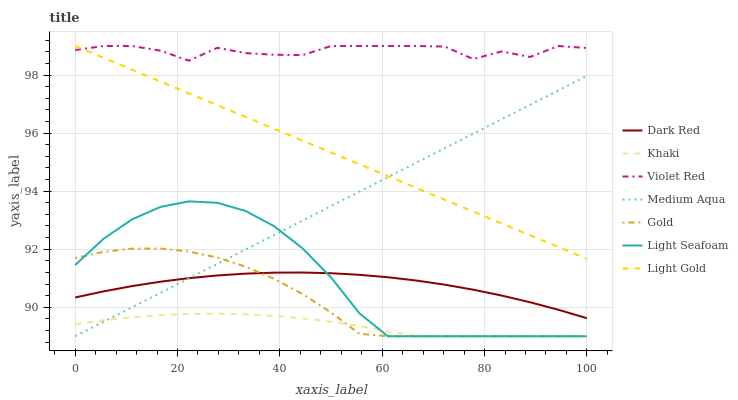Does Khaki have the minimum area under the curve?
Answer yes or no. Yes. Does Violet Red have the maximum area under the curve?
Answer yes or no. Yes. Does Gold have the minimum area under the curve?
Answer yes or no. No. Does Gold have the maximum area under the curve?
Answer yes or no. No. Is Medium Aqua the smoothest?
Answer yes or no. Yes. Is Violet Red the roughest?
Answer yes or no. Yes. Is Khaki the smoothest?
Answer yes or no. No. Is Khaki the roughest?
Answer yes or no. No. Does Khaki have the lowest value?
Answer yes or no. Yes. Does Dark Red have the lowest value?
Answer yes or no. No. Does Light Gold have the highest value?
Answer yes or no. Yes. Does Gold have the highest value?
Answer yes or no. No. Is Gold less than Violet Red?
Answer yes or no. Yes. Is Violet Red greater than Medium Aqua?
Answer yes or no. Yes. Does Medium Aqua intersect Khaki?
Answer yes or no. Yes. Is Medium Aqua less than Khaki?
Answer yes or no. No. Is Medium Aqua greater than Khaki?
Answer yes or no. No. Does Gold intersect Violet Red?
Answer yes or no. No. 